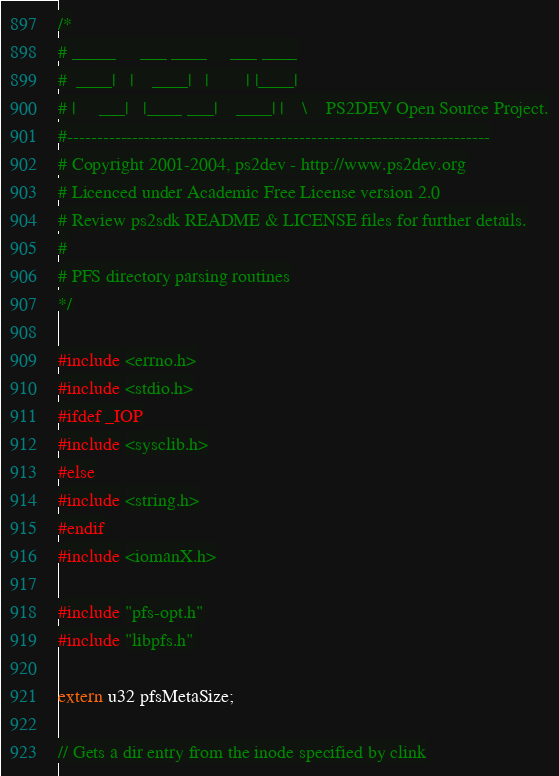Convert code to text. <code><loc_0><loc_0><loc_500><loc_500><_C_>/*
# _____     ___ ____     ___ ____
#  ____|   |    ____|   |        | |____|
# |     ___|   |____ ___|    ____| |    \    PS2DEV Open Source Project.
#-----------------------------------------------------------------------
# Copyright 2001-2004, ps2dev - http://www.ps2dev.org
# Licenced under Academic Free License version 2.0
# Review ps2sdk README & LICENSE files for further details.
#
# PFS directory parsing routines
*/

#include <errno.h>
#include <stdio.h>
#ifdef _IOP
#include <sysclib.h>
#else
#include <string.h>
#endif
#include <iomanX.h>

#include "pfs-opt.h"
#include "libpfs.h"

extern u32 pfsMetaSize;

// Gets a dir entry from the inode specified by clink</code> 